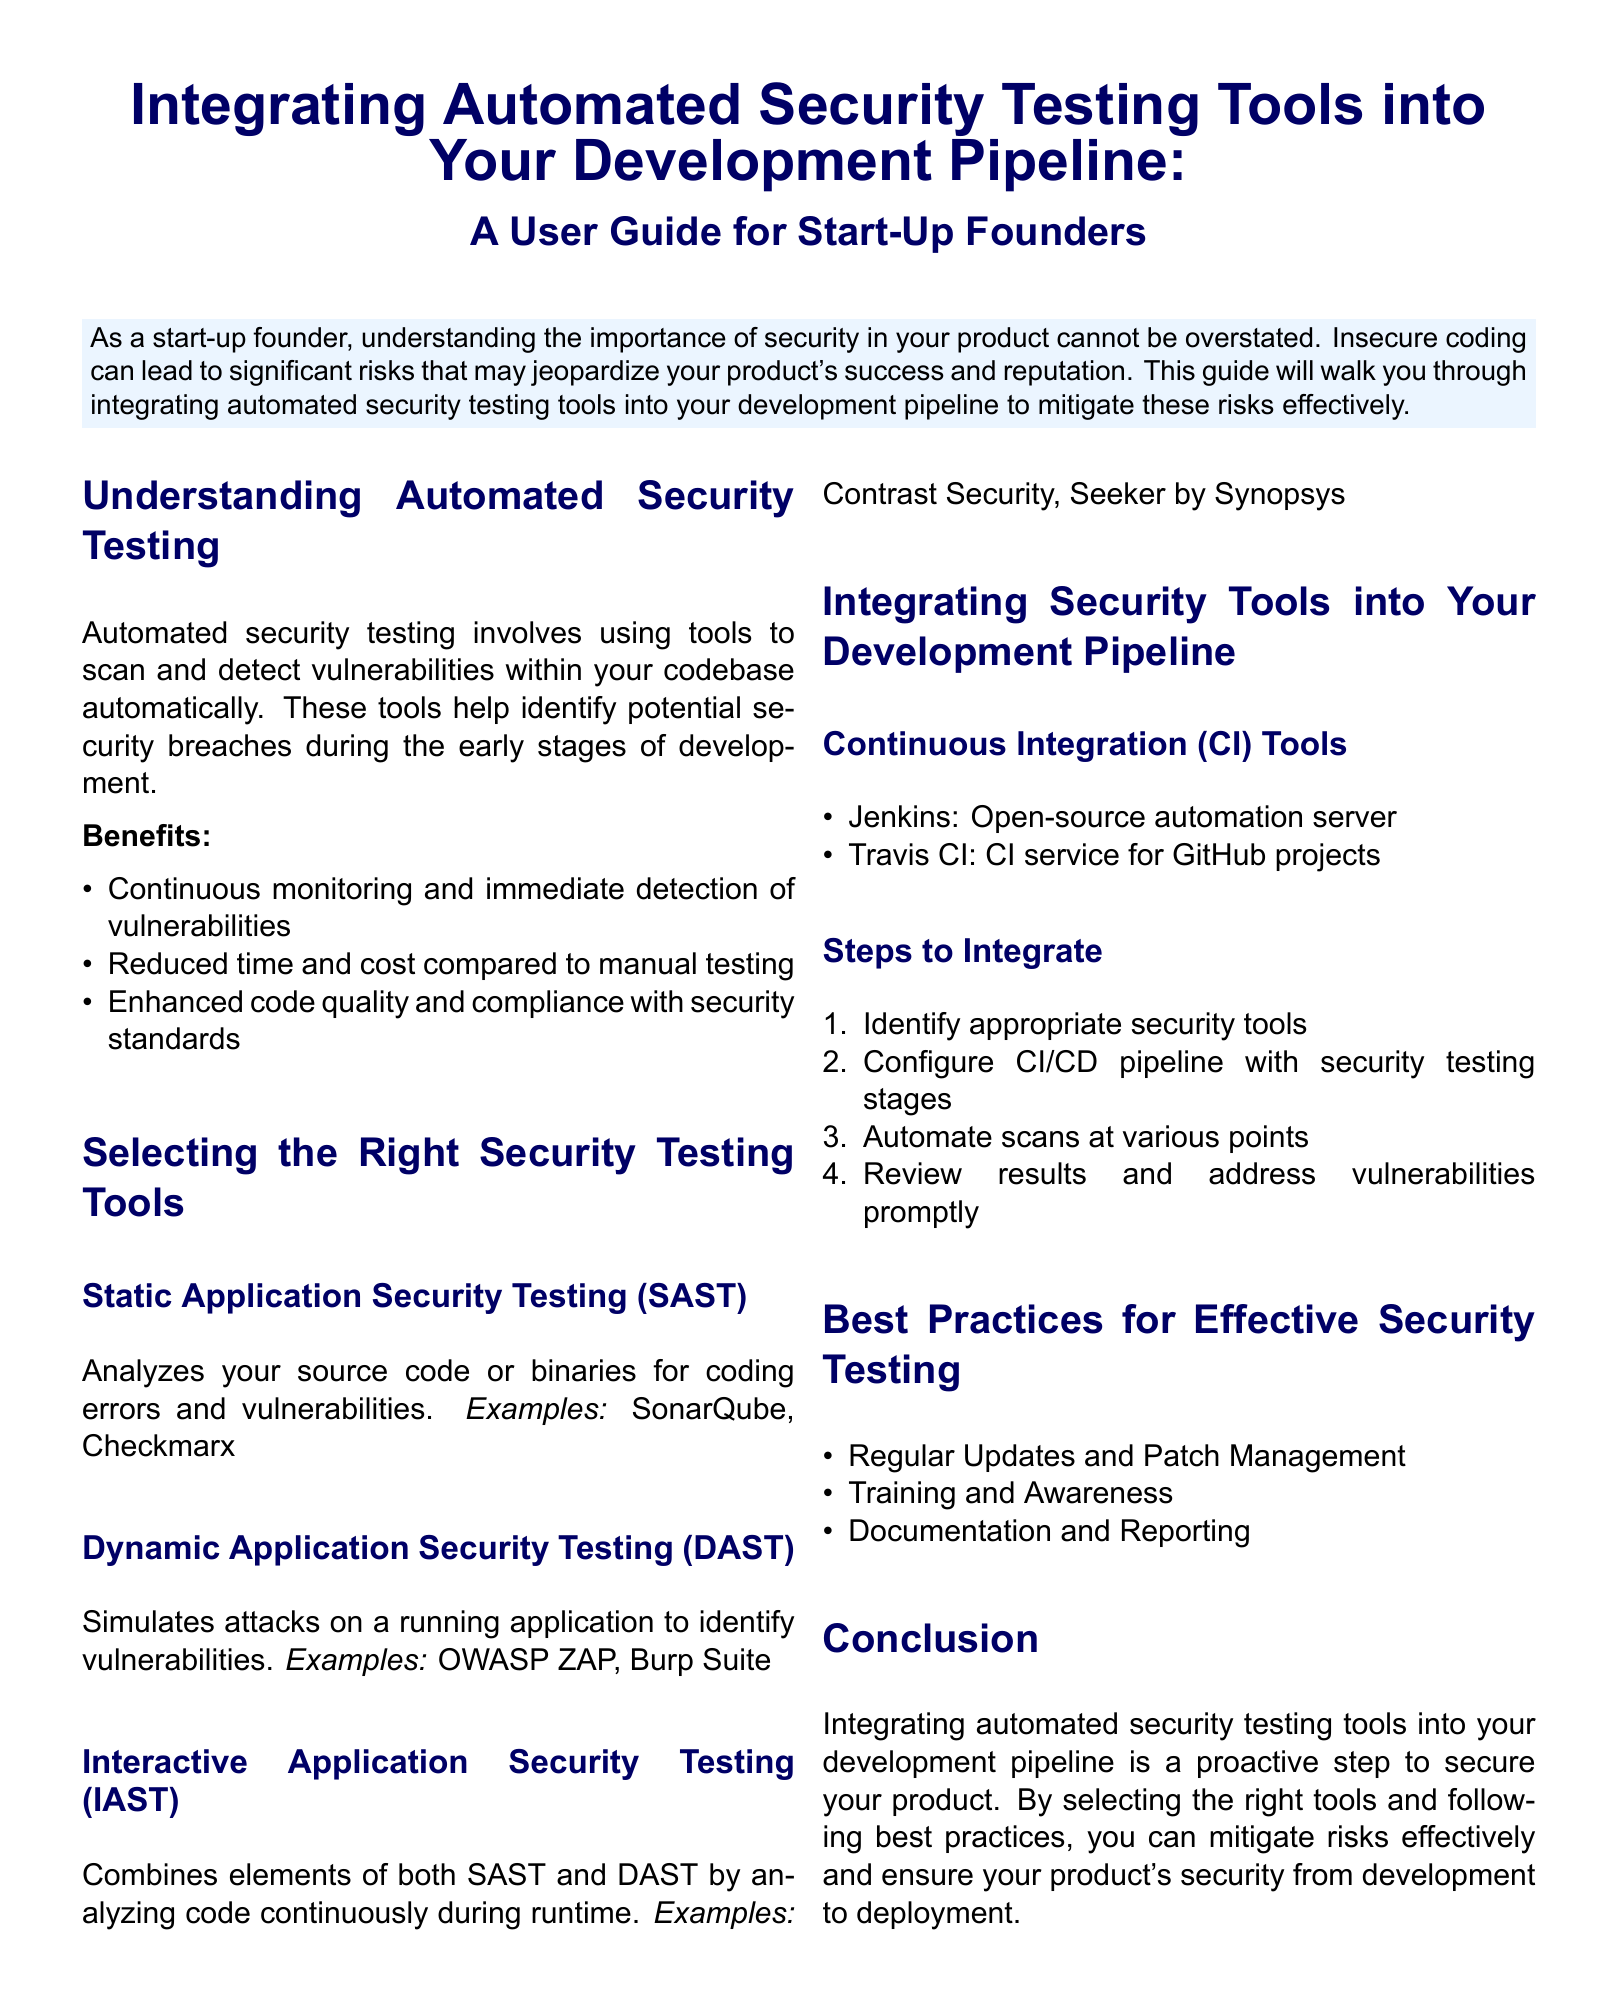What is the main focus of the user guide? The main focus of the user guide is on integrating automated security testing tools into the development pipeline to mitigate risks of insecure coding.
Answer: Integrating automated security testing tools What is SAST? SAST stands for Static Application Security Testing, which analyzes source code or binaries for coding errors and vulnerabilities.
Answer: Static Application Security Testing Name one example of DAST. An example of DAST is OWASP ZAP, which simulates attacks on a running application to identify vulnerabilities.
Answer: OWASP ZAP What are the first two steps to integrate security tools? The first two steps to integrate security tools are identifying appropriate security tools and configuring the CI/CD pipeline with security testing stages.
Answer: Identify appropriate security tools, Configure CI/CD pipeline How many benefits of automated security testing are listed? Three benefits of automated security testing are listed in the document.
Answer: Three What organization provides an example of a CI tool? Jenkins is provided as an example of an open-source automation server for continuous integration.
Answer: Jenkins What type of testing does IAST combine? IAST combines elements of both Static Application Security Testing and Dynamic Application Security Testing.
Answer: SAST and DAST What is one best practice mentioned for effective security testing? One best practice mentioned for effective security testing is regular updates and patch management.
Answer: Regular updates and patch management How many key tool examples are provided under the Static Application Security Testing section? Two key tool examples are provided under the Static Application Security Testing section.
Answer: Two 